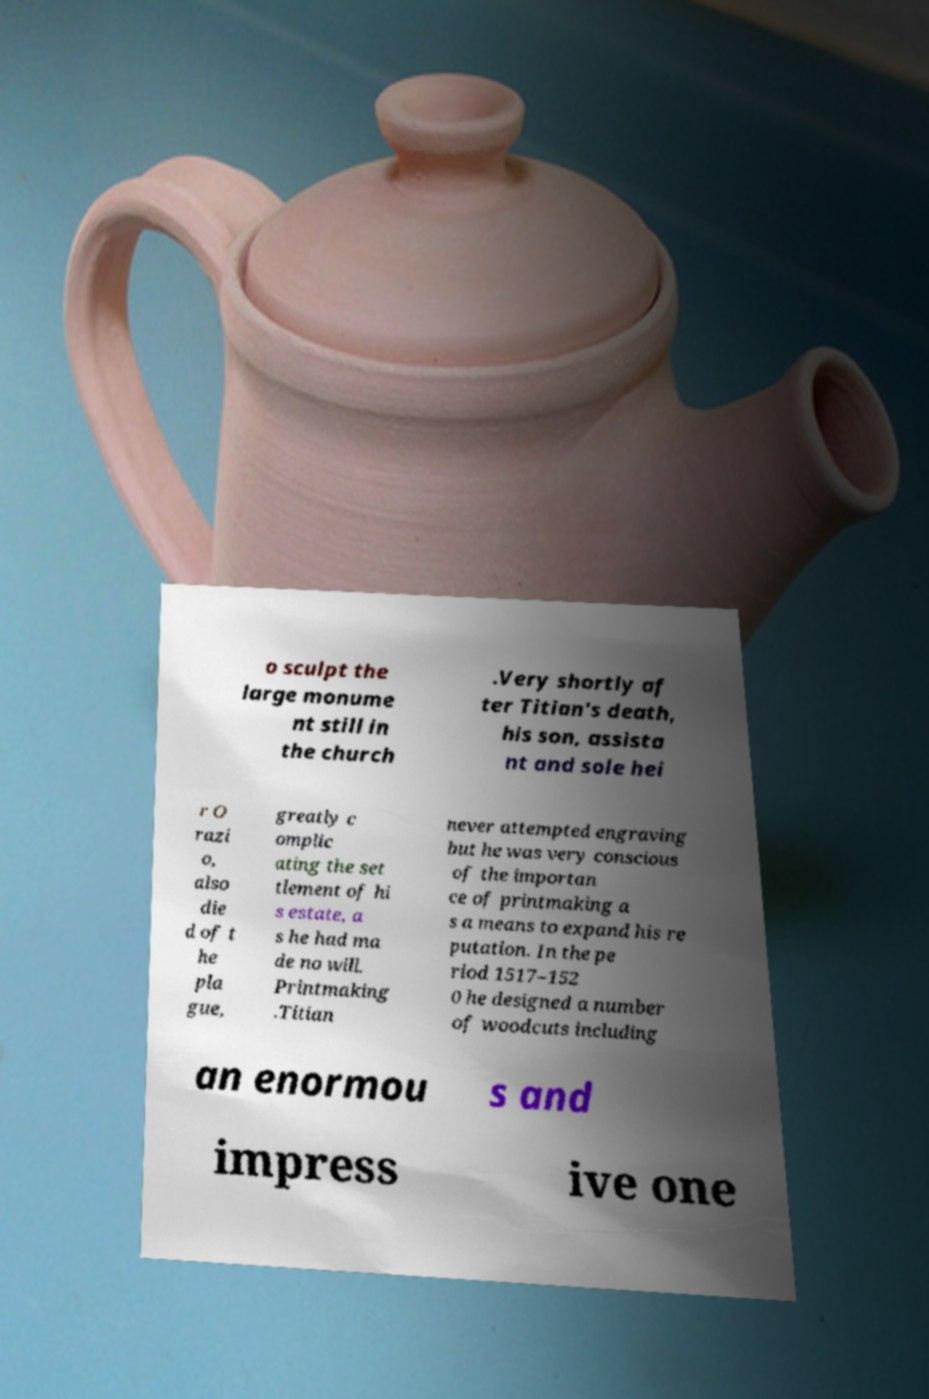Could you extract and type out the text from this image? o sculpt the large monume nt still in the church .Very shortly af ter Titian's death, his son, assista nt and sole hei r O razi o, also die d of t he pla gue, greatly c omplic ating the set tlement of hi s estate, a s he had ma de no will. Printmaking .Titian never attempted engraving but he was very conscious of the importan ce of printmaking a s a means to expand his re putation. In the pe riod 1517–152 0 he designed a number of woodcuts including an enormou s and impress ive one 